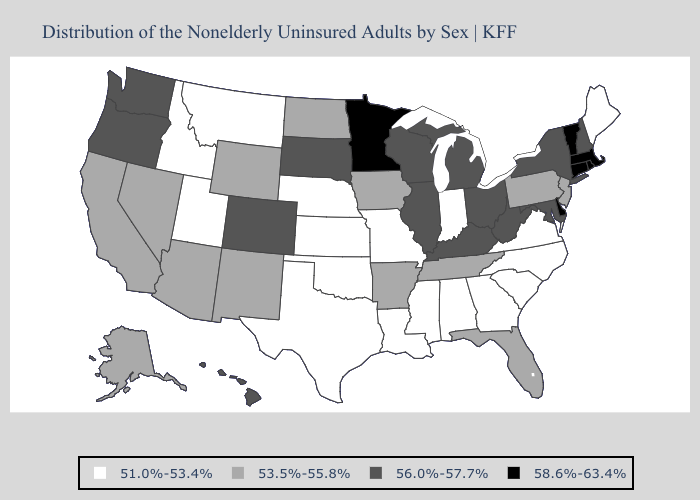Name the states that have a value in the range 56.0%-57.7%?
Quick response, please. Colorado, Hawaii, Illinois, Kentucky, Maryland, Michigan, New Hampshire, New York, Ohio, Oregon, South Dakota, Washington, West Virginia, Wisconsin. Name the states that have a value in the range 58.6%-63.4%?
Give a very brief answer. Connecticut, Delaware, Massachusetts, Minnesota, Rhode Island, Vermont. Name the states that have a value in the range 51.0%-53.4%?
Answer briefly. Alabama, Georgia, Idaho, Indiana, Kansas, Louisiana, Maine, Mississippi, Missouri, Montana, Nebraska, North Carolina, Oklahoma, South Carolina, Texas, Utah, Virginia. Does Wyoming have a lower value than Nevada?
Keep it brief. No. Name the states that have a value in the range 58.6%-63.4%?
Concise answer only. Connecticut, Delaware, Massachusetts, Minnesota, Rhode Island, Vermont. What is the value of Massachusetts?
Concise answer only. 58.6%-63.4%. Name the states that have a value in the range 53.5%-55.8%?
Concise answer only. Alaska, Arizona, Arkansas, California, Florida, Iowa, Nevada, New Jersey, New Mexico, North Dakota, Pennsylvania, Tennessee, Wyoming. What is the value of Alaska?
Keep it brief. 53.5%-55.8%. Does the map have missing data?
Keep it brief. No. Name the states that have a value in the range 56.0%-57.7%?
Answer briefly. Colorado, Hawaii, Illinois, Kentucky, Maryland, Michigan, New Hampshire, New York, Ohio, Oregon, South Dakota, Washington, West Virginia, Wisconsin. Name the states that have a value in the range 53.5%-55.8%?
Answer briefly. Alaska, Arizona, Arkansas, California, Florida, Iowa, Nevada, New Jersey, New Mexico, North Dakota, Pennsylvania, Tennessee, Wyoming. Which states have the lowest value in the Northeast?
Keep it brief. Maine. Does South Carolina have the highest value in the USA?
Give a very brief answer. No. What is the value of Pennsylvania?
Keep it brief. 53.5%-55.8%. 